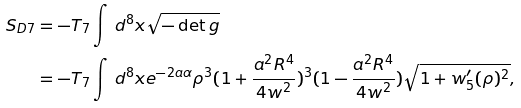<formula> <loc_0><loc_0><loc_500><loc_500>S _ { D 7 } & = - T _ { 7 } \int \, d ^ { 8 } x \sqrt { - \det g } \\ & = - T _ { 7 } \int \, d ^ { 8 } x e ^ { - 2 a \alpha } \rho ^ { 3 } ( 1 + \frac { a ^ { 2 } R ^ { 4 } } { 4 w ^ { 2 } } ) ^ { 3 } ( 1 - \frac { a ^ { 2 } R ^ { 4 } } { 4 w ^ { 2 } } ) \sqrt { 1 + w _ { 5 } ^ { \prime } ( \rho ) ^ { 2 } } ,</formula> 